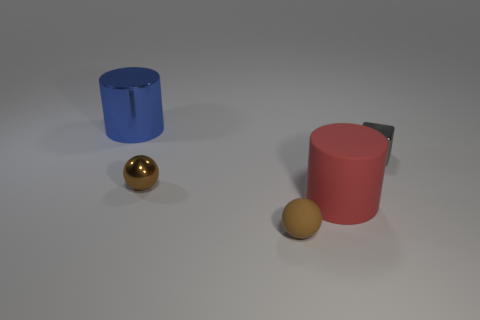What is the material of the other ball that is the same color as the rubber sphere?
Your answer should be very brief. Metal. There is a large object to the right of the blue shiny cylinder; is it the same shape as the large blue metal object?
Provide a short and direct response. Yes. Are there fewer brown metallic objects behind the blue thing than tiny brown balls?
Provide a short and direct response. Yes. Is there a metal thing of the same color as the metallic ball?
Ensure brevity in your answer.  No. There is a large blue metal thing; is its shape the same as the small metallic thing behind the tiny brown shiny thing?
Provide a short and direct response. No. Are there any brown things that have the same material as the small block?
Your answer should be very brief. Yes. Is there a red cylinder that is in front of the big thing in front of the big cylinder behind the cube?
Your response must be concise. No. What number of other things are there of the same shape as the tiny brown rubber thing?
Offer a very short reply. 1. What is the color of the cylinder behind the big thing right of the small brown ball behind the big red rubber cylinder?
Provide a succinct answer. Blue. What number of tiny shiny things are there?
Your answer should be very brief. 2. 